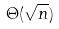<formula> <loc_0><loc_0><loc_500><loc_500>\Theta ( \sqrt { n } )</formula> 